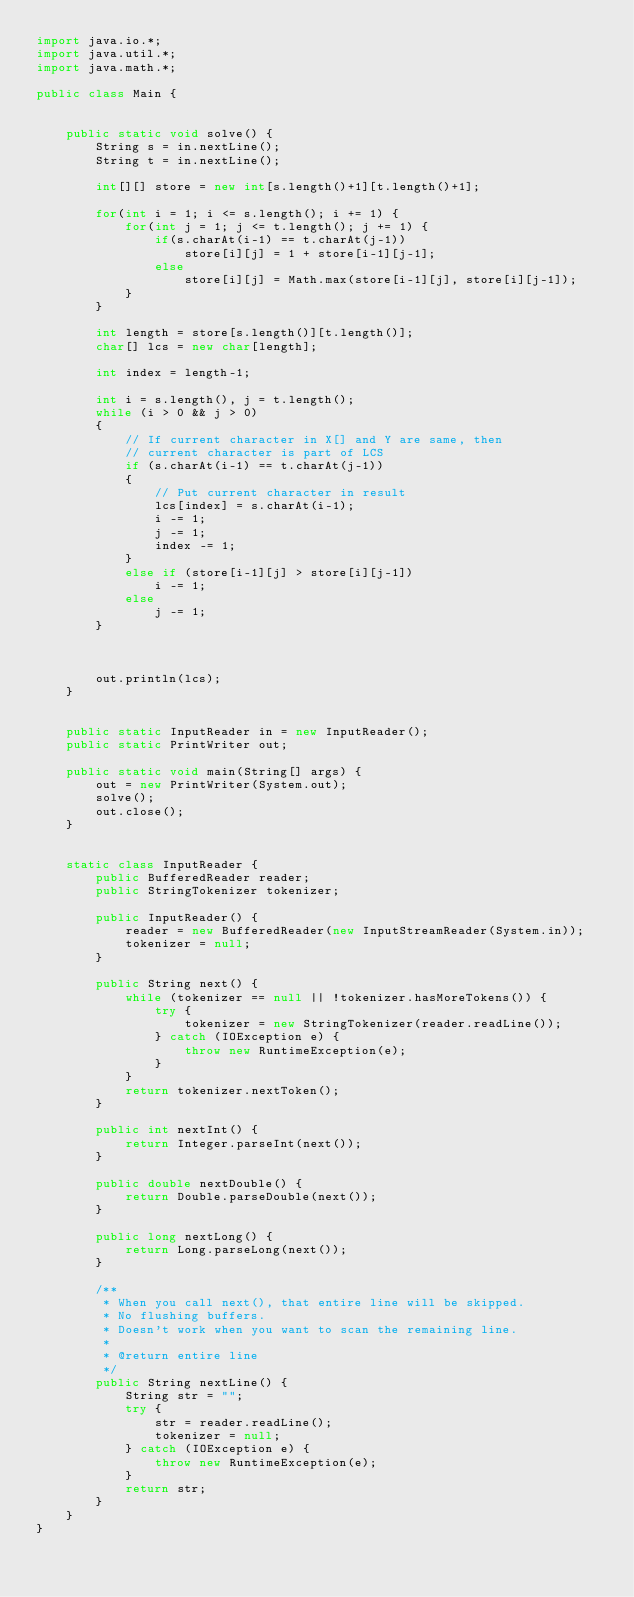<code> <loc_0><loc_0><loc_500><loc_500><_Java_>import java.io.*;
import java.util.*;
import java.math.*;

public class Main {


    public static void solve() {
        String s = in.nextLine();
        String t = in.nextLine();

        int[][] store = new int[s.length()+1][t.length()+1];

        for(int i = 1; i <= s.length(); i += 1) {
            for(int j = 1; j <= t.length(); j += 1) {
                if(s.charAt(i-1) == t.charAt(j-1))
                    store[i][j] = 1 + store[i-1][j-1];
                else
                    store[i][j] = Math.max(store[i-1][j], store[i][j-1]);
            }
        }

        int length = store[s.length()][t.length()];
        char[] lcs = new char[length];

        int index = length-1;

        int i = s.length(), j = t.length();
        while (i > 0 && j > 0)
        {
            // If current character in X[] and Y are same, then
            // current character is part of LCS
            if (s.charAt(i-1) == t.charAt(j-1))
            {
                // Put current character in result
                lcs[index] = s.charAt(i-1);
                i -= 1;
                j -= 1;
                index -= 1;
            }
            else if (store[i-1][j] > store[i][j-1])
                i -= 1;
            else
                j -= 1;
        }



        out.println(lcs);
    }


    public static InputReader in = new InputReader();
    public static PrintWriter out;

    public static void main(String[] args) {
        out = new PrintWriter(System.out);
        solve();
        out.close();
    }


    static class InputReader {
        public BufferedReader reader;
        public StringTokenizer tokenizer;

        public InputReader() {
            reader = new BufferedReader(new InputStreamReader(System.in));
            tokenizer = null;
        }

        public String next() {
            while (tokenizer == null || !tokenizer.hasMoreTokens()) {
                try {
                    tokenizer = new StringTokenizer(reader.readLine());
                } catch (IOException e) {
                    throw new RuntimeException(e);
                }
            }
            return tokenizer.nextToken();
        }

        public int nextInt() {
            return Integer.parseInt(next());
        }

        public double nextDouble() {
            return Double.parseDouble(next());
        }

        public long nextLong() {
            return Long.parseLong(next());
        }

        /**
         * When you call next(), that entire line will be skipped.
         * No flushing buffers.
         * Doesn't work when you want to scan the remaining line.
         *
         * @return entire line
         */
        public String nextLine() {
            String str = "";
            try {
                str = reader.readLine();
                tokenizer = null;
            } catch (IOException e) {
                throw new RuntimeException(e);
            }
            return str;
        }
    }
}</code> 